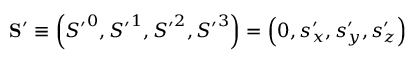<formula> <loc_0><loc_0><loc_500><loc_500>S ^ { \prime } \equiv \left ( { S ^ { \prime } } ^ { 0 } , { S ^ { \prime } } ^ { 1 } , { S ^ { \prime } } ^ { 2 } , { S ^ { \prime } } ^ { 3 } \right ) = \left ( 0 , s _ { x } ^ { \prime } , s _ { y } ^ { \prime } , s _ { z } ^ { \prime } \right )</formula> 